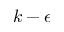Convert formula to latex. <formula><loc_0><loc_0><loc_500><loc_500>k - \epsilon</formula> 